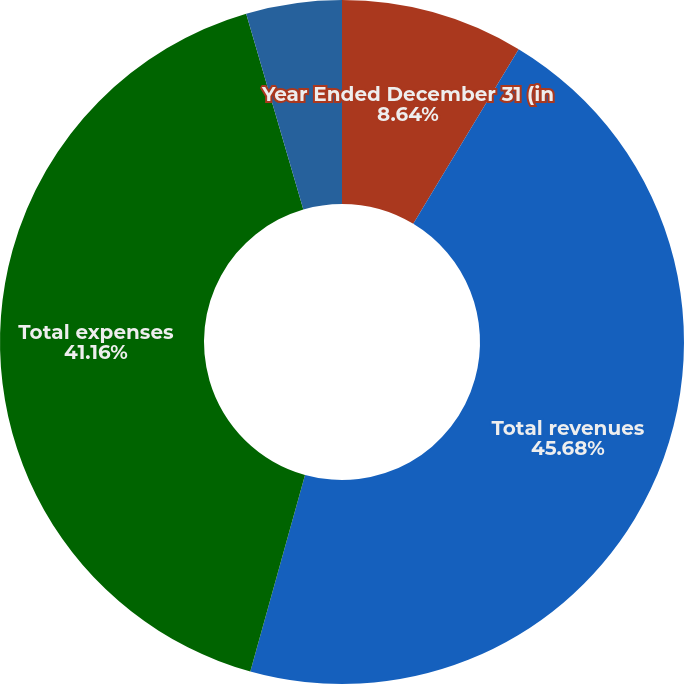Convert chart. <chart><loc_0><loc_0><loc_500><loc_500><pie_chart><fcel>Year Ended December 31 (in<fcel>Total revenues<fcel>Total expenses<fcel>Net income<nl><fcel>8.64%<fcel>45.68%<fcel>41.16%<fcel>4.52%<nl></chart> 